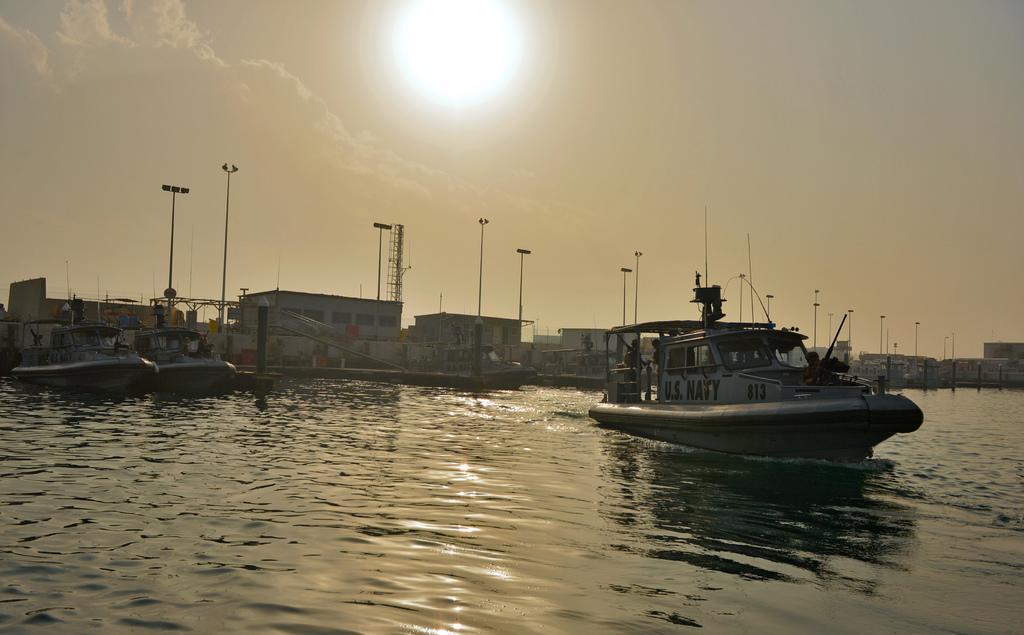Could you give a brief overview of what you see in this image? In this image we can see few ships on the water, there are few buildings, light poles, and the sky with sun in the background. 